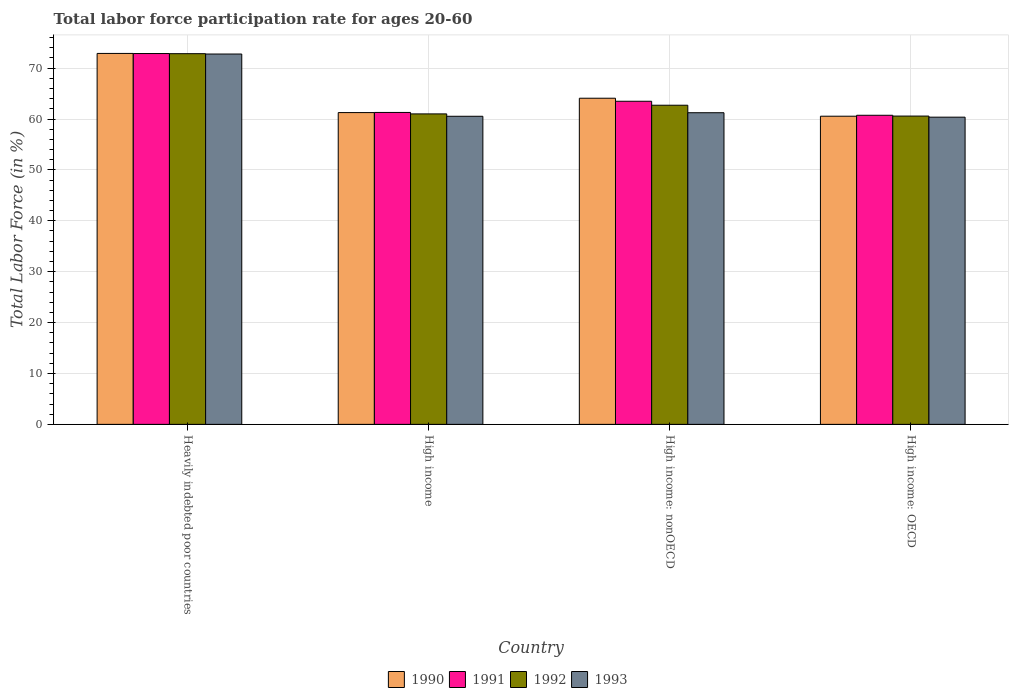How many different coloured bars are there?
Your response must be concise. 4. Are the number of bars per tick equal to the number of legend labels?
Ensure brevity in your answer.  Yes. How many bars are there on the 2nd tick from the right?
Your response must be concise. 4. What is the labor force participation rate in 1990 in High income: OECD?
Your answer should be compact. 60.55. Across all countries, what is the maximum labor force participation rate in 1990?
Offer a very short reply. 72.89. Across all countries, what is the minimum labor force participation rate in 1993?
Offer a very short reply. 60.36. In which country was the labor force participation rate in 1990 maximum?
Your response must be concise. Heavily indebted poor countries. In which country was the labor force participation rate in 1993 minimum?
Give a very brief answer. High income: OECD. What is the total labor force participation rate in 1992 in the graph?
Provide a short and direct response. 257.12. What is the difference between the labor force participation rate in 1993 in Heavily indebted poor countries and that in High income: OECD?
Make the answer very short. 12.4. What is the difference between the labor force participation rate in 1992 in High income: nonOECD and the labor force participation rate in 1990 in Heavily indebted poor countries?
Make the answer very short. -10.18. What is the average labor force participation rate in 1990 per country?
Give a very brief answer. 64.7. What is the difference between the labor force participation rate of/in 1990 and labor force participation rate of/in 1992 in High income: OECD?
Keep it short and to the point. -0.03. What is the ratio of the labor force participation rate in 1992 in High income to that in High income: OECD?
Your answer should be very brief. 1.01. Is the labor force participation rate in 1992 in High income: OECD less than that in High income: nonOECD?
Offer a terse response. Yes. Is the difference between the labor force participation rate in 1990 in Heavily indebted poor countries and High income greater than the difference between the labor force participation rate in 1992 in Heavily indebted poor countries and High income?
Keep it short and to the point. No. What is the difference between the highest and the second highest labor force participation rate in 1990?
Make the answer very short. 8.8. What is the difference between the highest and the lowest labor force participation rate in 1990?
Your answer should be very brief. 12.34. In how many countries, is the labor force participation rate in 1992 greater than the average labor force participation rate in 1992 taken over all countries?
Keep it short and to the point. 1. What does the 3rd bar from the left in Heavily indebted poor countries represents?
Your response must be concise. 1992. Is it the case that in every country, the sum of the labor force participation rate in 1991 and labor force participation rate in 1992 is greater than the labor force participation rate in 1993?
Provide a short and direct response. Yes. How many bars are there?
Your answer should be compact. 16. Are all the bars in the graph horizontal?
Keep it short and to the point. No. How many countries are there in the graph?
Make the answer very short. 4. Are the values on the major ticks of Y-axis written in scientific E-notation?
Your response must be concise. No. Does the graph contain grids?
Ensure brevity in your answer.  Yes. Where does the legend appear in the graph?
Your answer should be very brief. Bottom center. How many legend labels are there?
Your answer should be compact. 4. What is the title of the graph?
Keep it short and to the point. Total labor force participation rate for ages 20-60. Does "1983" appear as one of the legend labels in the graph?
Provide a short and direct response. No. What is the label or title of the Y-axis?
Make the answer very short. Total Labor Force (in %). What is the Total Labor Force (in %) in 1990 in Heavily indebted poor countries?
Your response must be concise. 72.89. What is the Total Labor Force (in %) in 1991 in Heavily indebted poor countries?
Provide a succinct answer. 72.86. What is the Total Labor Force (in %) of 1992 in Heavily indebted poor countries?
Give a very brief answer. 72.83. What is the Total Labor Force (in %) in 1993 in Heavily indebted poor countries?
Offer a terse response. 72.77. What is the Total Labor Force (in %) of 1990 in High income?
Offer a terse response. 61.26. What is the Total Labor Force (in %) in 1991 in High income?
Give a very brief answer. 61.29. What is the Total Labor Force (in %) of 1992 in High income?
Provide a succinct answer. 61. What is the Total Labor Force (in %) in 1993 in High income?
Provide a succinct answer. 60.54. What is the Total Labor Force (in %) of 1990 in High income: nonOECD?
Ensure brevity in your answer.  64.08. What is the Total Labor Force (in %) of 1991 in High income: nonOECD?
Give a very brief answer. 63.49. What is the Total Labor Force (in %) in 1992 in High income: nonOECD?
Your response must be concise. 62.71. What is the Total Labor Force (in %) in 1993 in High income: nonOECD?
Your response must be concise. 61.23. What is the Total Labor Force (in %) in 1990 in High income: OECD?
Provide a short and direct response. 60.55. What is the Total Labor Force (in %) in 1991 in High income: OECD?
Your answer should be compact. 60.73. What is the Total Labor Force (in %) of 1992 in High income: OECD?
Your response must be concise. 60.58. What is the Total Labor Force (in %) of 1993 in High income: OECD?
Provide a short and direct response. 60.36. Across all countries, what is the maximum Total Labor Force (in %) of 1990?
Your response must be concise. 72.89. Across all countries, what is the maximum Total Labor Force (in %) in 1991?
Give a very brief answer. 72.86. Across all countries, what is the maximum Total Labor Force (in %) in 1992?
Ensure brevity in your answer.  72.83. Across all countries, what is the maximum Total Labor Force (in %) of 1993?
Offer a terse response. 72.77. Across all countries, what is the minimum Total Labor Force (in %) in 1990?
Provide a succinct answer. 60.55. Across all countries, what is the minimum Total Labor Force (in %) in 1991?
Offer a very short reply. 60.73. Across all countries, what is the minimum Total Labor Force (in %) in 1992?
Offer a terse response. 60.58. Across all countries, what is the minimum Total Labor Force (in %) in 1993?
Your response must be concise. 60.36. What is the total Total Labor Force (in %) in 1990 in the graph?
Provide a short and direct response. 258.78. What is the total Total Labor Force (in %) in 1991 in the graph?
Provide a short and direct response. 258.37. What is the total Total Labor Force (in %) in 1992 in the graph?
Provide a short and direct response. 257.12. What is the total Total Labor Force (in %) in 1993 in the graph?
Your response must be concise. 254.9. What is the difference between the Total Labor Force (in %) in 1990 in Heavily indebted poor countries and that in High income?
Your answer should be compact. 11.62. What is the difference between the Total Labor Force (in %) of 1991 in Heavily indebted poor countries and that in High income?
Provide a succinct answer. 11.57. What is the difference between the Total Labor Force (in %) in 1992 in Heavily indebted poor countries and that in High income?
Provide a short and direct response. 11.83. What is the difference between the Total Labor Force (in %) of 1993 in Heavily indebted poor countries and that in High income?
Your response must be concise. 12.23. What is the difference between the Total Labor Force (in %) of 1990 in Heavily indebted poor countries and that in High income: nonOECD?
Offer a very short reply. 8.8. What is the difference between the Total Labor Force (in %) of 1991 in Heavily indebted poor countries and that in High income: nonOECD?
Your response must be concise. 9.37. What is the difference between the Total Labor Force (in %) in 1992 in Heavily indebted poor countries and that in High income: nonOECD?
Provide a short and direct response. 10.13. What is the difference between the Total Labor Force (in %) of 1993 in Heavily indebted poor countries and that in High income: nonOECD?
Offer a terse response. 11.53. What is the difference between the Total Labor Force (in %) in 1990 in Heavily indebted poor countries and that in High income: OECD?
Make the answer very short. 12.34. What is the difference between the Total Labor Force (in %) of 1991 in Heavily indebted poor countries and that in High income: OECD?
Your answer should be very brief. 12.13. What is the difference between the Total Labor Force (in %) of 1992 in Heavily indebted poor countries and that in High income: OECD?
Your answer should be compact. 12.26. What is the difference between the Total Labor Force (in %) of 1993 in Heavily indebted poor countries and that in High income: OECD?
Your response must be concise. 12.4. What is the difference between the Total Labor Force (in %) of 1990 in High income and that in High income: nonOECD?
Offer a very short reply. -2.82. What is the difference between the Total Labor Force (in %) of 1991 in High income and that in High income: nonOECD?
Your answer should be compact. -2.2. What is the difference between the Total Labor Force (in %) of 1992 in High income and that in High income: nonOECD?
Provide a succinct answer. -1.7. What is the difference between the Total Labor Force (in %) in 1993 in High income and that in High income: nonOECD?
Your answer should be compact. -0.7. What is the difference between the Total Labor Force (in %) in 1990 in High income and that in High income: OECD?
Keep it short and to the point. 0.71. What is the difference between the Total Labor Force (in %) in 1991 in High income and that in High income: OECD?
Keep it short and to the point. 0.55. What is the difference between the Total Labor Force (in %) of 1992 in High income and that in High income: OECD?
Keep it short and to the point. 0.43. What is the difference between the Total Labor Force (in %) in 1993 in High income and that in High income: OECD?
Your answer should be very brief. 0.17. What is the difference between the Total Labor Force (in %) in 1990 in High income: nonOECD and that in High income: OECD?
Offer a terse response. 3.53. What is the difference between the Total Labor Force (in %) in 1991 in High income: nonOECD and that in High income: OECD?
Make the answer very short. 2.75. What is the difference between the Total Labor Force (in %) in 1992 in High income: nonOECD and that in High income: OECD?
Provide a succinct answer. 2.13. What is the difference between the Total Labor Force (in %) in 1993 in High income: nonOECD and that in High income: OECD?
Offer a terse response. 0.87. What is the difference between the Total Labor Force (in %) in 1990 in Heavily indebted poor countries and the Total Labor Force (in %) in 1991 in High income?
Your response must be concise. 11.6. What is the difference between the Total Labor Force (in %) of 1990 in Heavily indebted poor countries and the Total Labor Force (in %) of 1992 in High income?
Your answer should be compact. 11.88. What is the difference between the Total Labor Force (in %) of 1990 in Heavily indebted poor countries and the Total Labor Force (in %) of 1993 in High income?
Your response must be concise. 12.35. What is the difference between the Total Labor Force (in %) of 1991 in Heavily indebted poor countries and the Total Labor Force (in %) of 1992 in High income?
Your answer should be very brief. 11.86. What is the difference between the Total Labor Force (in %) of 1991 in Heavily indebted poor countries and the Total Labor Force (in %) of 1993 in High income?
Your response must be concise. 12.32. What is the difference between the Total Labor Force (in %) in 1992 in Heavily indebted poor countries and the Total Labor Force (in %) in 1993 in High income?
Make the answer very short. 12.3. What is the difference between the Total Labor Force (in %) of 1990 in Heavily indebted poor countries and the Total Labor Force (in %) of 1991 in High income: nonOECD?
Your answer should be very brief. 9.4. What is the difference between the Total Labor Force (in %) of 1990 in Heavily indebted poor countries and the Total Labor Force (in %) of 1992 in High income: nonOECD?
Provide a short and direct response. 10.18. What is the difference between the Total Labor Force (in %) in 1990 in Heavily indebted poor countries and the Total Labor Force (in %) in 1993 in High income: nonOECD?
Offer a very short reply. 11.65. What is the difference between the Total Labor Force (in %) in 1991 in Heavily indebted poor countries and the Total Labor Force (in %) in 1992 in High income: nonOECD?
Your response must be concise. 10.15. What is the difference between the Total Labor Force (in %) in 1991 in Heavily indebted poor countries and the Total Labor Force (in %) in 1993 in High income: nonOECD?
Make the answer very short. 11.63. What is the difference between the Total Labor Force (in %) in 1992 in Heavily indebted poor countries and the Total Labor Force (in %) in 1993 in High income: nonOECD?
Your answer should be compact. 11.6. What is the difference between the Total Labor Force (in %) of 1990 in Heavily indebted poor countries and the Total Labor Force (in %) of 1991 in High income: OECD?
Keep it short and to the point. 12.15. What is the difference between the Total Labor Force (in %) in 1990 in Heavily indebted poor countries and the Total Labor Force (in %) in 1992 in High income: OECD?
Offer a very short reply. 12.31. What is the difference between the Total Labor Force (in %) in 1990 in Heavily indebted poor countries and the Total Labor Force (in %) in 1993 in High income: OECD?
Make the answer very short. 12.52. What is the difference between the Total Labor Force (in %) of 1991 in Heavily indebted poor countries and the Total Labor Force (in %) of 1992 in High income: OECD?
Your answer should be very brief. 12.29. What is the difference between the Total Labor Force (in %) in 1991 in Heavily indebted poor countries and the Total Labor Force (in %) in 1993 in High income: OECD?
Provide a succinct answer. 12.5. What is the difference between the Total Labor Force (in %) of 1992 in Heavily indebted poor countries and the Total Labor Force (in %) of 1993 in High income: OECD?
Your response must be concise. 12.47. What is the difference between the Total Labor Force (in %) in 1990 in High income and the Total Labor Force (in %) in 1991 in High income: nonOECD?
Your answer should be compact. -2.23. What is the difference between the Total Labor Force (in %) in 1990 in High income and the Total Labor Force (in %) in 1992 in High income: nonOECD?
Your response must be concise. -1.44. What is the difference between the Total Labor Force (in %) in 1990 in High income and the Total Labor Force (in %) in 1993 in High income: nonOECD?
Your response must be concise. 0.03. What is the difference between the Total Labor Force (in %) in 1991 in High income and the Total Labor Force (in %) in 1992 in High income: nonOECD?
Your answer should be compact. -1.42. What is the difference between the Total Labor Force (in %) of 1991 in High income and the Total Labor Force (in %) of 1993 in High income: nonOECD?
Offer a terse response. 0.06. What is the difference between the Total Labor Force (in %) in 1992 in High income and the Total Labor Force (in %) in 1993 in High income: nonOECD?
Give a very brief answer. -0.23. What is the difference between the Total Labor Force (in %) of 1990 in High income and the Total Labor Force (in %) of 1991 in High income: OECD?
Ensure brevity in your answer.  0.53. What is the difference between the Total Labor Force (in %) in 1990 in High income and the Total Labor Force (in %) in 1992 in High income: OECD?
Ensure brevity in your answer.  0.69. What is the difference between the Total Labor Force (in %) in 1990 in High income and the Total Labor Force (in %) in 1993 in High income: OECD?
Ensure brevity in your answer.  0.9. What is the difference between the Total Labor Force (in %) in 1991 in High income and the Total Labor Force (in %) in 1992 in High income: OECD?
Keep it short and to the point. 0.71. What is the difference between the Total Labor Force (in %) in 1991 in High income and the Total Labor Force (in %) in 1993 in High income: OECD?
Your response must be concise. 0.93. What is the difference between the Total Labor Force (in %) in 1992 in High income and the Total Labor Force (in %) in 1993 in High income: OECD?
Offer a very short reply. 0.64. What is the difference between the Total Labor Force (in %) in 1990 in High income: nonOECD and the Total Labor Force (in %) in 1991 in High income: OECD?
Offer a very short reply. 3.35. What is the difference between the Total Labor Force (in %) of 1990 in High income: nonOECD and the Total Labor Force (in %) of 1992 in High income: OECD?
Provide a short and direct response. 3.51. What is the difference between the Total Labor Force (in %) in 1990 in High income: nonOECD and the Total Labor Force (in %) in 1993 in High income: OECD?
Your answer should be very brief. 3.72. What is the difference between the Total Labor Force (in %) in 1991 in High income: nonOECD and the Total Labor Force (in %) in 1992 in High income: OECD?
Your answer should be compact. 2.91. What is the difference between the Total Labor Force (in %) in 1991 in High income: nonOECD and the Total Labor Force (in %) in 1993 in High income: OECD?
Your answer should be compact. 3.12. What is the difference between the Total Labor Force (in %) in 1992 in High income: nonOECD and the Total Labor Force (in %) in 1993 in High income: OECD?
Give a very brief answer. 2.34. What is the average Total Labor Force (in %) in 1990 per country?
Your answer should be very brief. 64.7. What is the average Total Labor Force (in %) of 1991 per country?
Provide a succinct answer. 64.59. What is the average Total Labor Force (in %) in 1992 per country?
Give a very brief answer. 64.28. What is the average Total Labor Force (in %) in 1993 per country?
Offer a very short reply. 63.73. What is the difference between the Total Labor Force (in %) of 1990 and Total Labor Force (in %) of 1991 in Heavily indebted poor countries?
Offer a very short reply. 0.02. What is the difference between the Total Labor Force (in %) of 1990 and Total Labor Force (in %) of 1992 in Heavily indebted poor countries?
Your answer should be compact. 0.05. What is the difference between the Total Labor Force (in %) in 1990 and Total Labor Force (in %) in 1993 in Heavily indebted poor countries?
Provide a succinct answer. 0.12. What is the difference between the Total Labor Force (in %) of 1991 and Total Labor Force (in %) of 1992 in Heavily indebted poor countries?
Make the answer very short. 0.03. What is the difference between the Total Labor Force (in %) of 1991 and Total Labor Force (in %) of 1993 in Heavily indebted poor countries?
Keep it short and to the point. 0.09. What is the difference between the Total Labor Force (in %) of 1992 and Total Labor Force (in %) of 1993 in Heavily indebted poor countries?
Provide a short and direct response. 0.07. What is the difference between the Total Labor Force (in %) of 1990 and Total Labor Force (in %) of 1991 in High income?
Provide a succinct answer. -0.03. What is the difference between the Total Labor Force (in %) of 1990 and Total Labor Force (in %) of 1992 in High income?
Provide a short and direct response. 0.26. What is the difference between the Total Labor Force (in %) of 1990 and Total Labor Force (in %) of 1993 in High income?
Provide a succinct answer. 0.73. What is the difference between the Total Labor Force (in %) of 1991 and Total Labor Force (in %) of 1992 in High income?
Your answer should be very brief. 0.29. What is the difference between the Total Labor Force (in %) in 1991 and Total Labor Force (in %) in 1993 in High income?
Your response must be concise. 0.75. What is the difference between the Total Labor Force (in %) in 1992 and Total Labor Force (in %) in 1993 in High income?
Provide a succinct answer. 0.47. What is the difference between the Total Labor Force (in %) of 1990 and Total Labor Force (in %) of 1991 in High income: nonOECD?
Provide a short and direct response. 0.59. What is the difference between the Total Labor Force (in %) in 1990 and Total Labor Force (in %) in 1992 in High income: nonOECD?
Your response must be concise. 1.38. What is the difference between the Total Labor Force (in %) in 1990 and Total Labor Force (in %) in 1993 in High income: nonOECD?
Offer a terse response. 2.85. What is the difference between the Total Labor Force (in %) of 1991 and Total Labor Force (in %) of 1992 in High income: nonOECD?
Your answer should be compact. 0.78. What is the difference between the Total Labor Force (in %) in 1991 and Total Labor Force (in %) in 1993 in High income: nonOECD?
Give a very brief answer. 2.25. What is the difference between the Total Labor Force (in %) in 1992 and Total Labor Force (in %) in 1993 in High income: nonOECD?
Your answer should be compact. 1.47. What is the difference between the Total Labor Force (in %) of 1990 and Total Labor Force (in %) of 1991 in High income: OECD?
Give a very brief answer. -0.18. What is the difference between the Total Labor Force (in %) in 1990 and Total Labor Force (in %) in 1992 in High income: OECD?
Provide a succinct answer. -0.03. What is the difference between the Total Labor Force (in %) in 1990 and Total Labor Force (in %) in 1993 in High income: OECD?
Your answer should be compact. 0.19. What is the difference between the Total Labor Force (in %) in 1991 and Total Labor Force (in %) in 1992 in High income: OECD?
Your response must be concise. 0.16. What is the difference between the Total Labor Force (in %) in 1991 and Total Labor Force (in %) in 1993 in High income: OECD?
Ensure brevity in your answer.  0.37. What is the difference between the Total Labor Force (in %) in 1992 and Total Labor Force (in %) in 1993 in High income: OECD?
Ensure brevity in your answer.  0.21. What is the ratio of the Total Labor Force (in %) of 1990 in Heavily indebted poor countries to that in High income?
Ensure brevity in your answer.  1.19. What is the ratio of the Total Labor Force (in %) of 1991 in Heavily indebted poor countries to that in High income?
Offer a very short reply. 1.19. What is the ratio of the Total Labor Force (in %) of 1992 in Heavily indebted poor countries to that in High income?
Offer a very short reply. 1.19. What is the ratio of the Total Labor Force (in %) in 1993 in Heavily indebted poor countries to that in High income?
Offer a terse response. 1.2. What is the ratio of the Total Labor Force (in %) in 1990 in Heavily indebted poor countries to that in High income: nonOECD?
Keep it short and to the point. 1.14. What is the ratio of the Total Labor Force (in %) in 1991 in Heavily indebted poor countries to that in High income: nonOECD?
Provide a short and direct response. 1.15. What is the ratio of the Total Labor Force (in %) in 1992 in Heavily indebted poor countries to that in High income: nonOECD?
Your response must be concise. 1.16. What is the ratio of the Total Labor Force (in %) of 1993 in Heavily indebted poor countries to that in High income: nonOECD?
Give a very brief answer. 1.19. What is the ratio of the Total Labor Force (in %) of 1990 in Heavily indebted poor countries to that in High income: OECD?
Offer a very short reply. 1.2. What is the ratio of the Total Labor Force (in %) of 1991 in Heavily indebted poor countries to that in High income: OECD?
Ensure brevity in your answer.  1.2. What is the ratio of the Total Labor Force (in %) of 1992 in Heavily indebted poor countries to that in High income: OECD?
Keep it short and to the point. 1.2. What is the ratio of the Total Labor Force (in %) of 1993 in Heavily indebted poor countries to that in High income: OECD?
Make the answer very short. 1.21. What is the ratio of the Total Labor Force (in %) in 1990 in High income to that in High income: nonOECD?
Offer a very short reply. 0.96. What is the ratio of the Total Labor Force (in %) in 1991 in High income to that in High income: nonOECD?
Keep it short and to the point. 0.97. What is the ratio of the Total Labor Force (in %) in 1992 in High income to that in High income: nonOECD?
Your answer should be very brief. 0.97. What is the ratio of the Total Labor Force (in %) of 1990 in High income to that in High income: OECD?
Ensure brevity in your answer.  1.01. What is the ratio of the Total Labor Force (in %) in 1991 in High income to that in High income: OECD?
Provide a succinct answer. 1.01. What is the ratio of the Total Labor Force (in %) of 1992 in High income to that in High income: OECD?
Make the answer very short. 1.01. What is the ratio of the Total Labor Force (in %) in 1993 in High income to that in High income: OECD?
Offer a terse response. 1. What is the ratio of the Total Labor Force (in %) of 1990 in High income: nonOECD to that in High income: OECD?
Offer a very short reply. 1.06. What is the ratio of the Total Labor Force (in %) of 1991 in High income: nonOECD to that in High income: OECD?
Your answer should be compact. 1.05. What is the ratio of the Total Labor Force (in %) of 1992 in High income: nonOECD to that in High income: OECD?
Ensure brevity in your answer.  1.04. What is the ratio of the Total Labor Force (in %) of 1993 in High income: nonOECD to that in High income: OECD?
Make the answer very short. 1.01. What is the difference between the highest and the second highest Total Labor Force (in %) of 1990?
Offer a very short reply. 8.8. What is the difference between the highest and the second highest Total Labor Force (in %) in 1991?
Your answer should be very brief. 9.37. What is the difference between the highest and the second highest Total Labor Force (in %) in 1992?
Offer a very short reply. 10.13. What is the difference between the highest and the second highest Total Labor Force (in %) of 1993?
Offer a very short reply. 11.53. What is the difference between the highest and the lowest Total Labor Force (in %) of 1990?
Your answer should be very brief. 12.34. What is the difference between the highest and the lowest Total Labor Force (in %) in 1991?
Your response must be concise. 12.13. What is the difference between the highest and the lowest Total Labor Force (in %) in 1992?
Your answer should be compact. 12.26. What is the difference between the highest and the lowest Total Labor Force (in %) in 1993?
Offer a terse response. 12.4. 